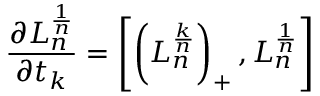<formula> <loc_0><loc_0><loc_500><loc_500>{ \frac { \partial L _ { n } ^ { \frac { 1 } { n } } } { \partial t _ { k } } } = \left [ \left ( L _ { n } ^ { \frac { k } { n } } \right ) _ { + } , L _ { n } ^ { \frac { 1 } { n } } \right ]</formula> 